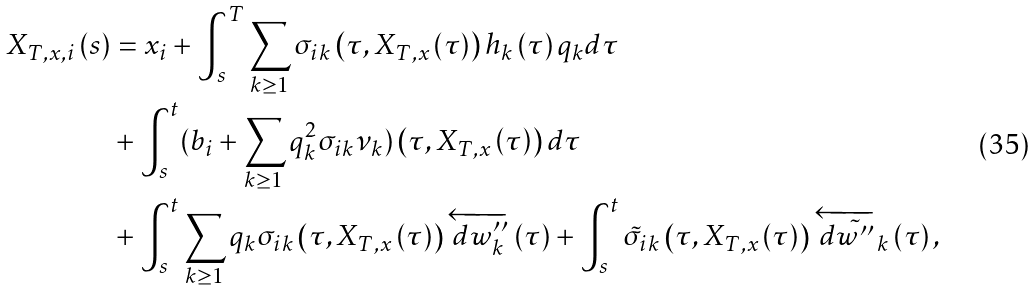<formula> <loc_0><loc_0><loc_500><loc_500>X _ { T , x , i } \left ( s \right ) & = x _ { i } + \int _ { s } ^ { T } \sum _ { k \geq 1 } \sigma _ { i k } \left ( \tau , X _ { T , x } \left ( \tau \right ) \right ) h _ { k } \left ( \tau \right ) q _ { k } d \tau \\ & + \int _ { s } ^ { t } ( b _ { i } + \sum _ { k \geq 1 } q _ { k } ^ { 2 } \sigma _ { i k } \nu _ { k } ) \left ( \tau , X _ { T , x } \left ( \tau \right ) \right ) d \tau \\ & + \int _ { s } ^ { t } \sum _ { k \geq 1 } q _ { k } \sigma _ { i k } \left ( \tau , X _ { T , x } \left ( \tau \right ) \right ) \overleftarrow { d w ^ { \prime \prime } _ { k } } \left ( \tau \right ) + \int _ { s } ^ { t } \tilde { \sigma } _ { i k } \left ( \tau , X _ { T , x } \left ( \tau \right ) \right ) \overleftarrow { d \tilde { w ^ { \prime \prime } } } _ { k } \left ( \tau \right ) ,</formula> 